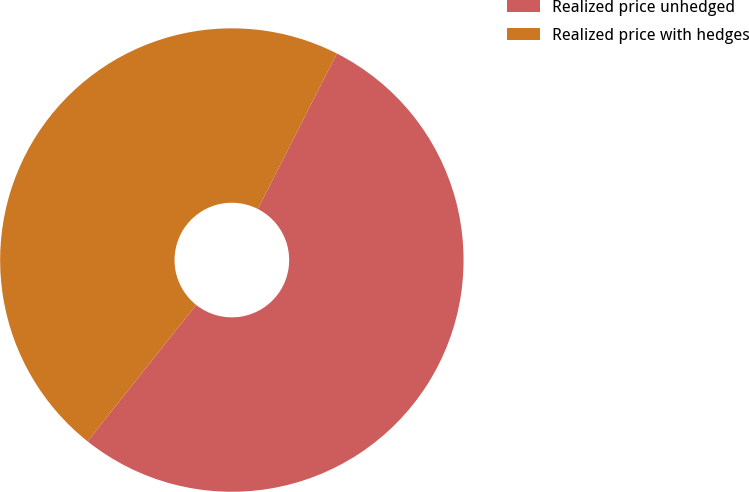Convert chart to OTSL. <chart><loc_0><loc_0><loc_500><loc_500><pie_chart><fcel>Realized price unhedged<fcel>Realized price with hedges<nl><fcel>53.21%<fcel>46.79%<nl></chart> 